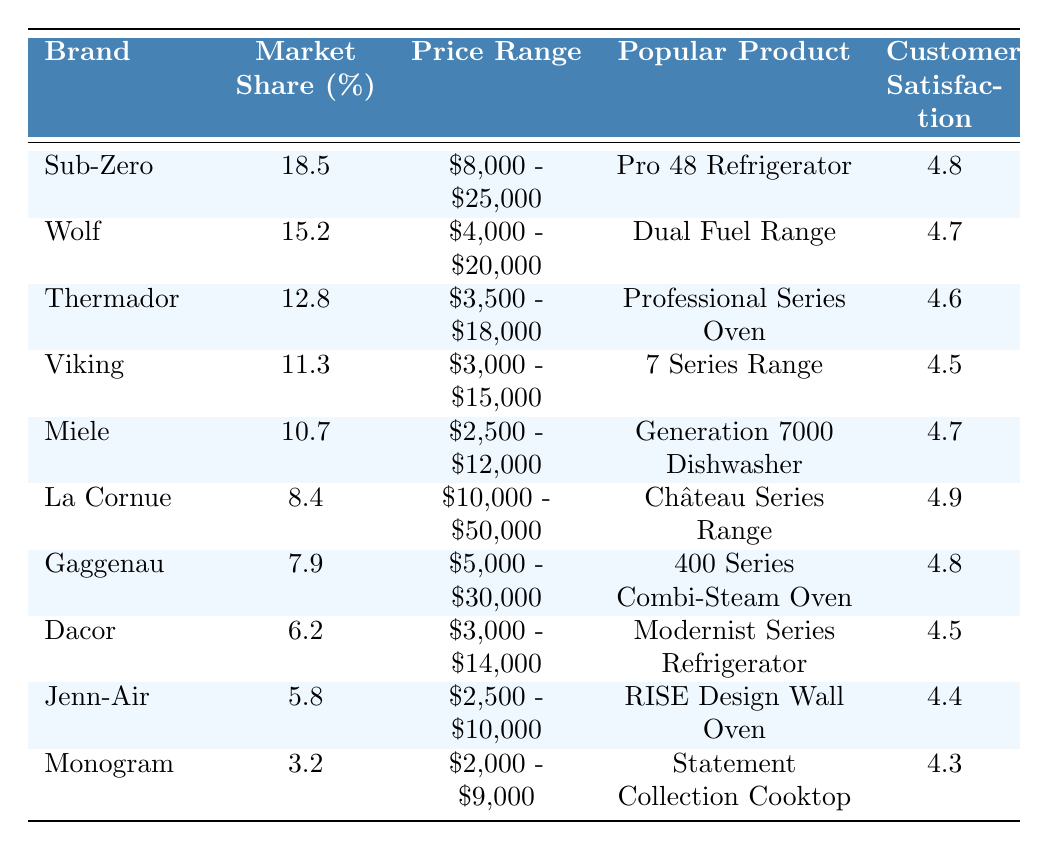What is the brand with the highest market share? Sub-Zero has the highest market share, which is listed as 18.5% in the table.
Answer: Sub-Zero Which brand has a customer satisfaction rating of 4.9? The brand La Cornue is indicated in the table as having a customer satisfaction rating of 4.9.
Answer: La Cornue What is the price range of the popular product "Dual Fuel Range"? The price range for the Dual Fuel Range, which is associated with the Wolf brand, is $4,000 - $20,000 based on the information in the table.
Answer: $4,000 - $20,000 Which two brands have a market share of over 10%? The brands with a market share over 10% are Sub-Zero (18.5%) and Wolf (15.2%) as observed in the table.
Answer: Sub-Zero and Wolf If you consider brands with a customer satisfaction above 4.6, how many brands meet this criterion? The brands Sub-Zero (4.8), Miele (4.7), La Cornue (4.9), and Gaggenau (4.8) have customer satisfaction ratings above 4.6, totaling four brands.
Answer: 4 What is the average market share of the top three brands? The top three brands are Sub-Zero (18.5%), Wolf (15.2%), and Thermador (12.8%). Adding these gives 18.5 + 15.2 + 12.8 = 46.5, and dividing by 3 yields an average market share of 46.5 / 3 = 15.5%.
Answer: 15.5% Is Miele's popular product the "Generation 7000 Dishwasher"? Yes, according to the table, the popular product associated with the Miele brand is indeed the Generation 7000 Dishwasher.
Answer: Yes Which brand has the lowest customer satisfaction rating? The brand with the lowest customer satisfaction rating is Monogram, which has a rating of 4.3 based on the data provided in the table.
Answer: Monogram How many brands have a price range that starts at $3,000? The brands with price ranges starting at $3,000 are Viking ($3,000 - $15,000), Dacor ($3,000 - $14,000), and La Cornue ($10,000 - $50,000), which makes a total of three brands.
Answer: 3 If we look at brands priced above $10,000, what is the market share of those brands? The brands priced above $10,000 are Sub-Zero ($8,000 - $25,000), La Cornue ($10,000 - $50,000), and Gaggenau ($5,000 - $30,000); their market shares are 18.5%, 8.4%, and 7.9%, combining for a total market share of 18.5 + 8.4 + 7.9 = 34.8%.
Answer: 34.8% 